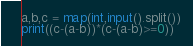Convert code to text. <code><loc_0><loc_0><loc_500><loc_500><_Python_>a,b,c = map(int,input().split())
print((c-(a-b))*(c-(a-b)>=0))</code> 